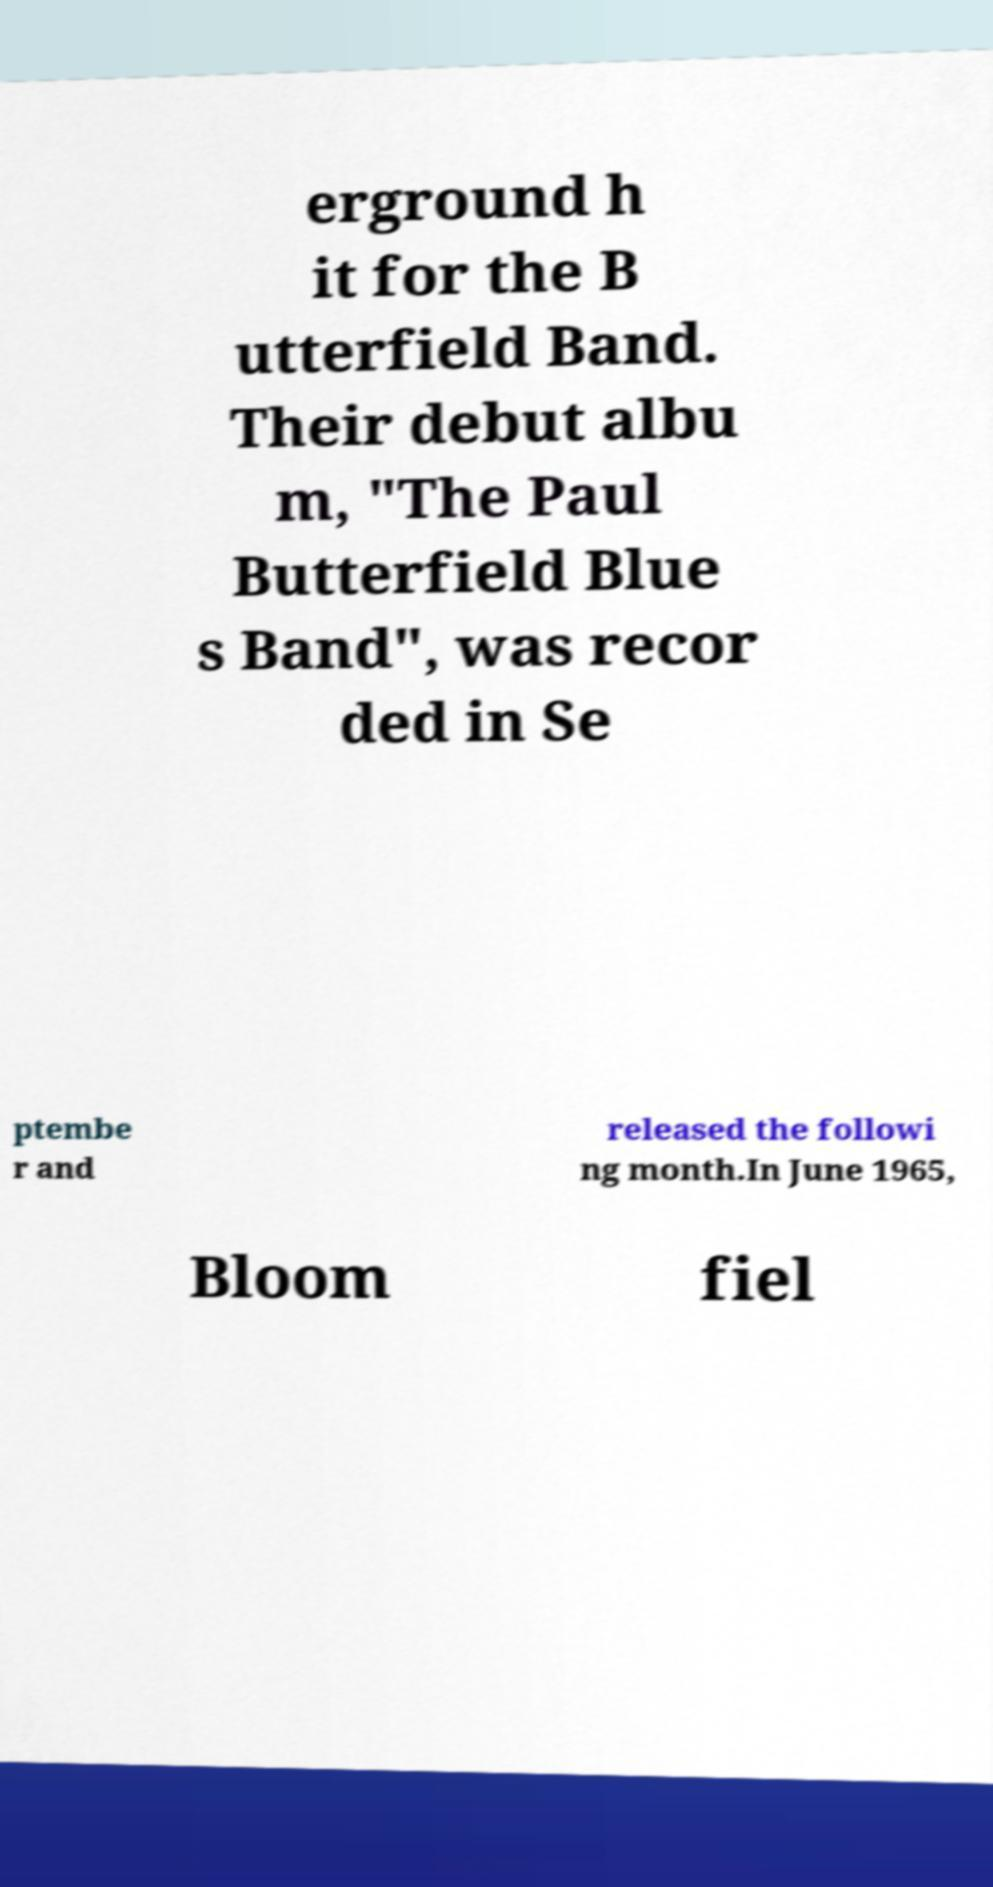Can you accurately transcribe the text from the provided image for me? erground h it for the B utterfield Band. Their debut albu m, "The Paul Butterfield Blue s Band", was recor ded in Se ptembe r and released the followi ng month.In June 1965, Bloom fiel 